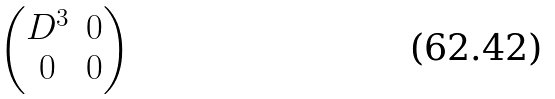Convert formula to latex. <formula><loc_0><loc_0><loc_500><loc_500>\begin{pmatrix} D ^ { 3 } & 0 \\ 0 & 0 \\ \end{pmatrix}</formula> 